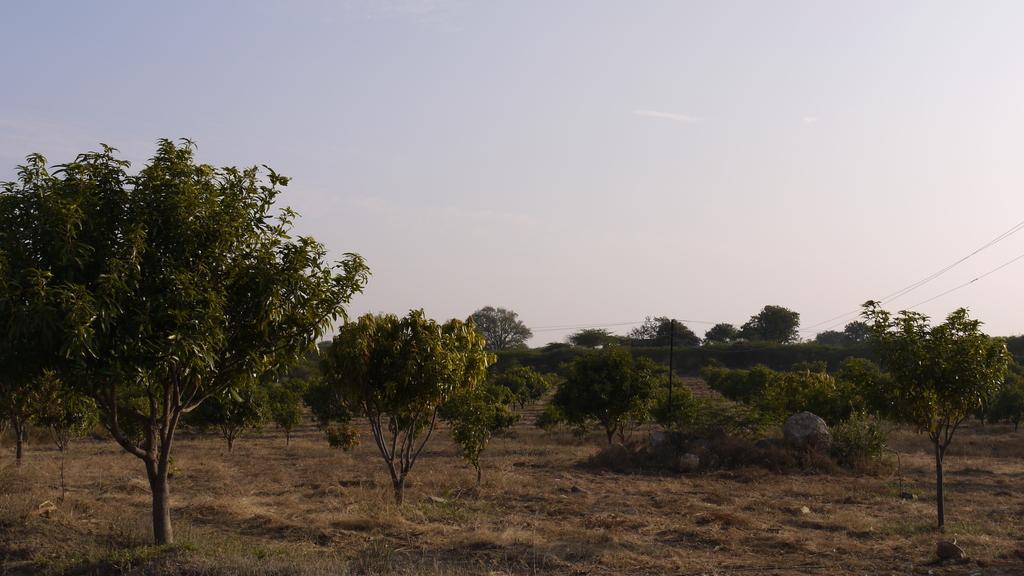In one or two sentences, can you explain what this image depicts? In this picture we can see there are trees, grass and an electric pole with cables. Behind the trees there is a sky. 